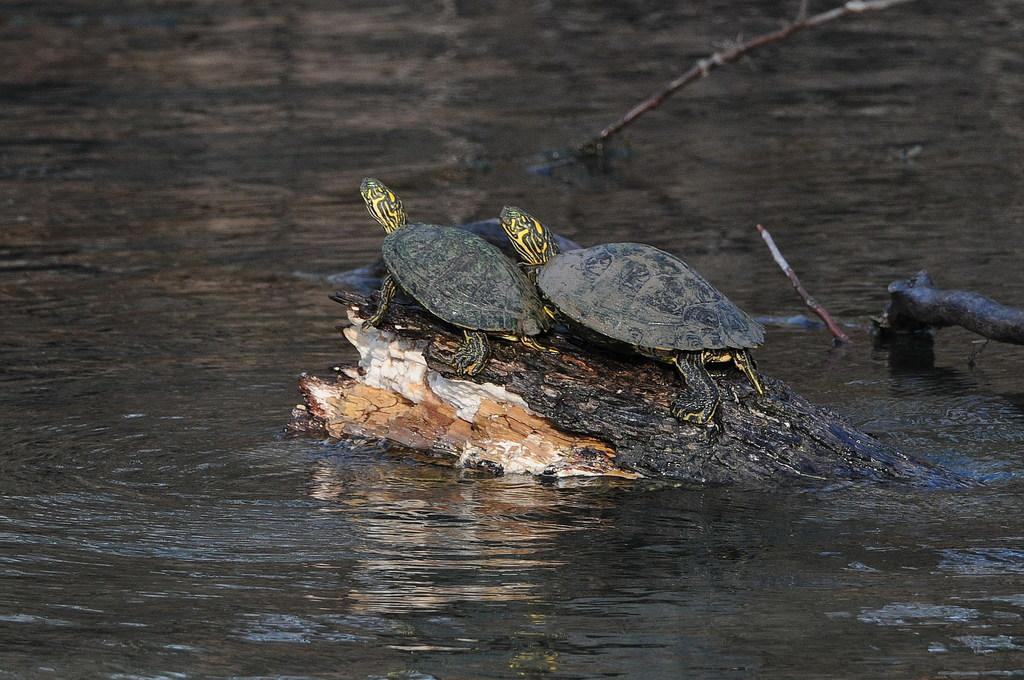How many tortoises are in the image? There are two tortoises in the image. What are the tortoises resting on? The tortoises are on a broken tree trunk. Where is the tree trunk located? The tree trunk is on the water. What else can be seen in the background of the image? There are other objects visible in the background. What type of powder can be seen on the tortoises' shells in the image? There is no powder visible on the tortoises' shells in the image. Can you tell me how the tortoises are walking on the water in the image? The tortoises are not walking on the water; they are resting on a broken tree trunk that is floating on the water. 